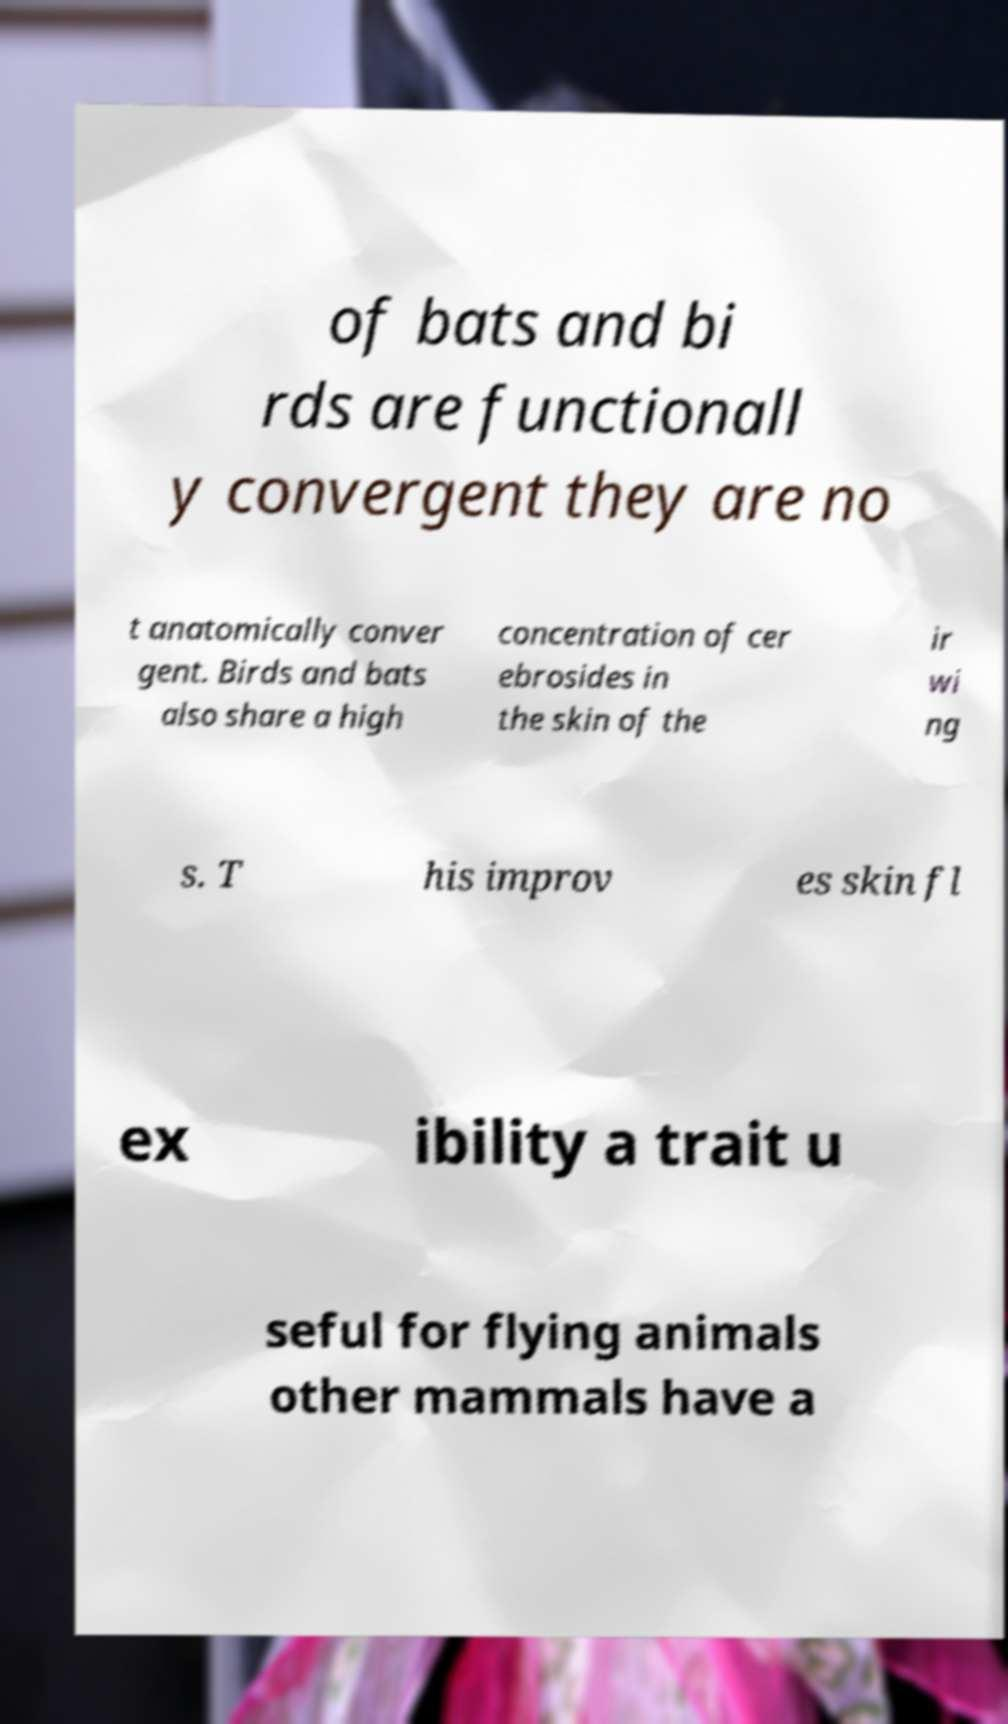Can you accurately transcribe the text from the provided image for me? of bats and bi rds are functionall y convergent they are no t anatomically conver gent. Birds and bats also share a high concentration of cer ebrosides in the skin of the ir wi ng s. T his improv es skin fl ex ibility a trait u seful for flying animals other mammals have a 